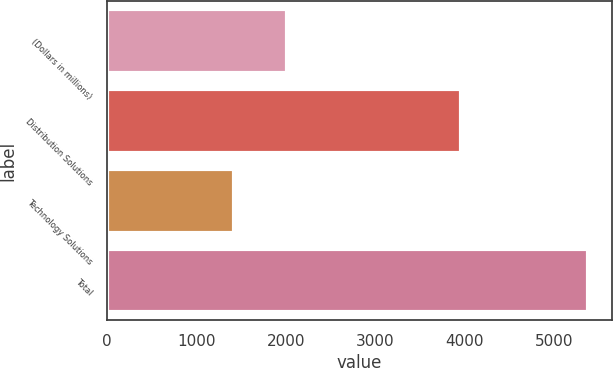Convert chart. <chart><loc_0><loc_0><loc_500><loc_500><bar_chart><fcel>(Dollars in millions)<fcel>Distribution Solutions<fcel>Technology Solutions<fcel>Total<nl><fcel>2009<fcel>3955<fcel>1423<fcel>5378<nl></chart> 